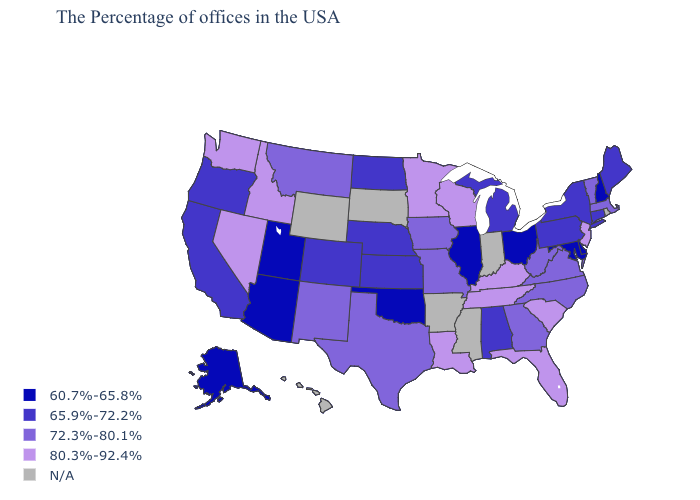Among the states that border North Dakota , which have the highest value?
Be succinct. Minnesota. Does Arizona have the lowest value in the USA?
Short answer required. Yes. Which states have the lowest value in the USA?
Give a very brief answer. New Hampshire, Delaware, Maryland, Ohio, Illinois, Oklahoma, Utah, Arizona, Alaska. Among the states that border Minnesota , does North Dakota have the lowest value?
Give a very brief answer. Yes. How many symbols are there in the legend?
Give a very brief answer. 5. Name the states that have a value in the range 60.7%-65.8%?
Write a very short answer. New Hampshire, Delaware, Maryland, Ohio, Illinois, Oklahoma, Utah, Arizona, Alaska. Among the states that border Tennessee , which have the lowest value?
Answer briefly. Alabama. Name the states that have a value in the range 60.7%-65.8%?
Give a very brief answer. New Hampshire, Delaware, Maryland, Ohio, Illinois, Oklahoma, Utah, Arizona, Alaska. What is the value of Maine?
Be succinct. 65.9%-72.2%. Is the legend a continuous bar?
Keep it brief. No. What is the value of Nebraska?
Concise answer only. 65.9%-72.2%. Name the states that have a value in the range 65.9%-72.2%?
Concise answer only. Maine, Connecticut, New York, Pennsylvania, Michigan, Alabama, Kansas, Nebraska, North Dakota, Colorado, California, Oregon. What is the highest value in the MidWest ?
Keep it brief. 80.3%-92.4%. 